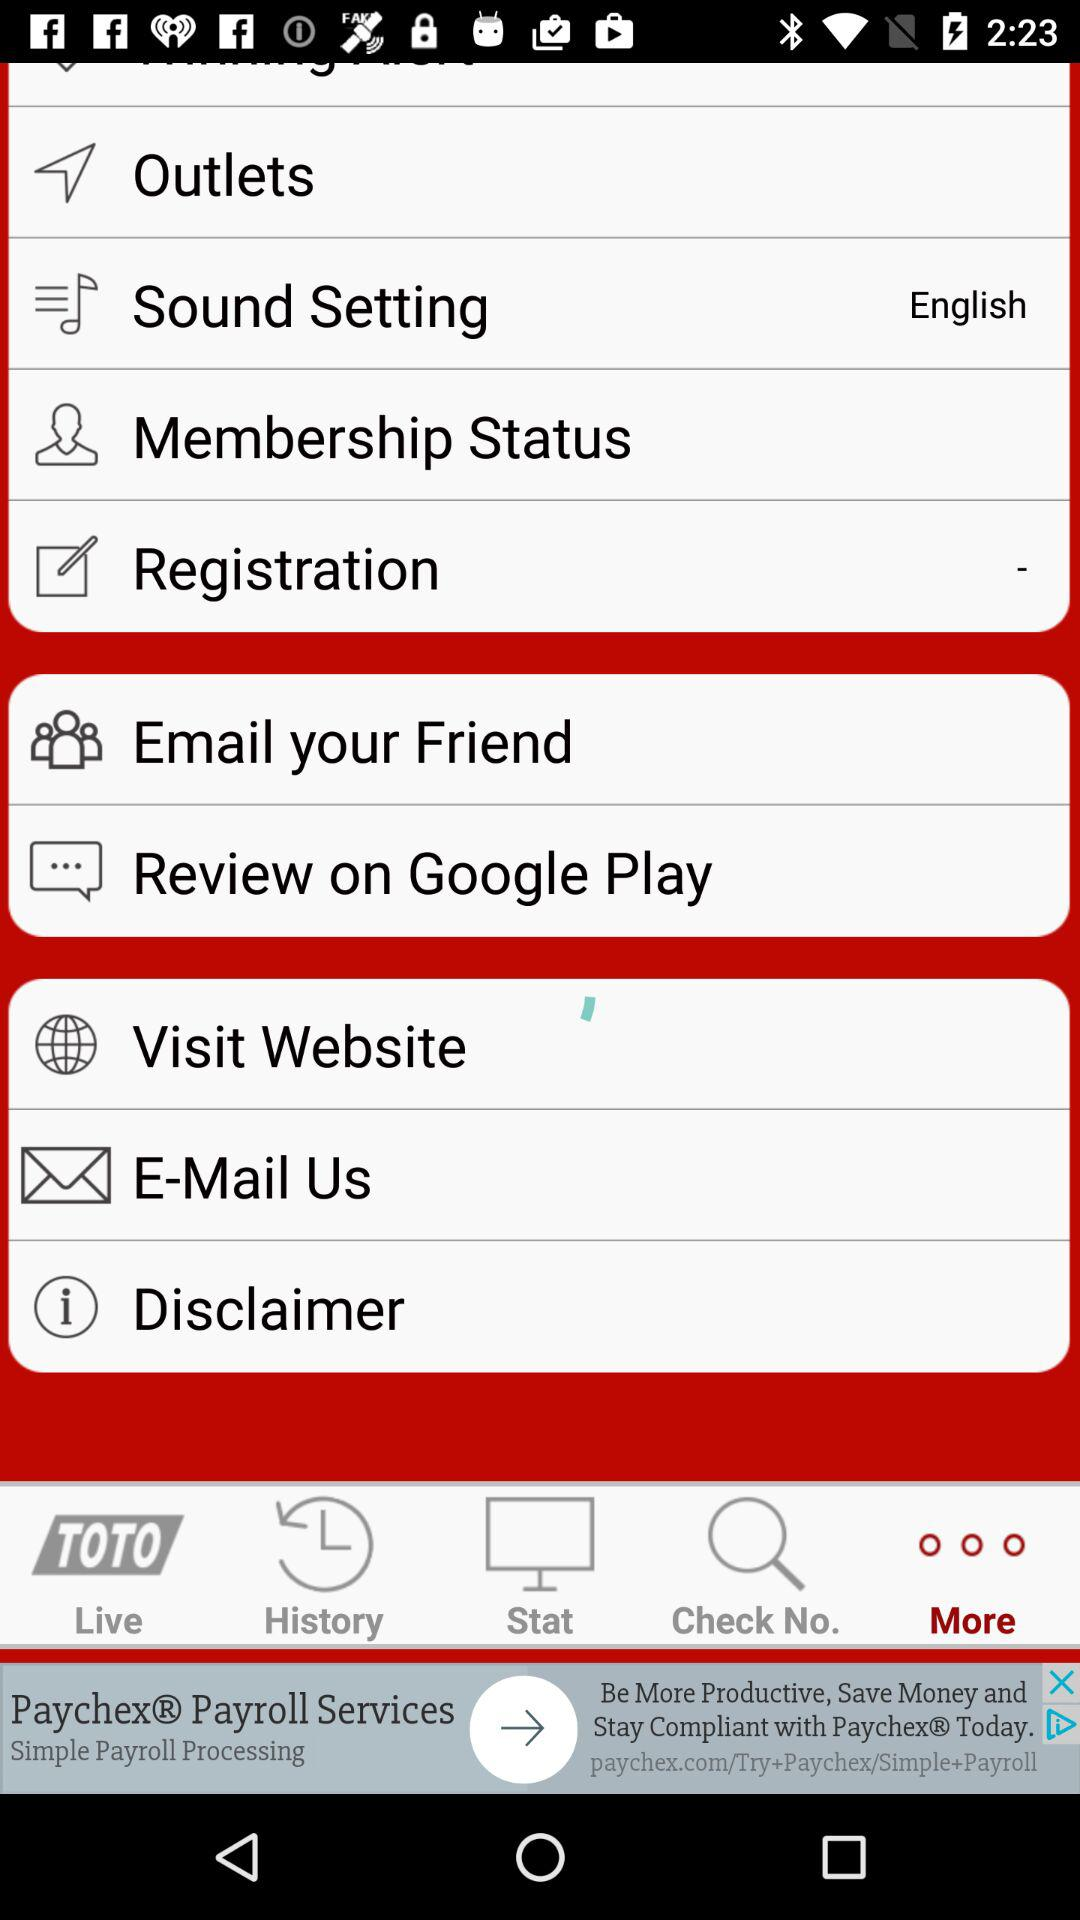Which tab is currently selected in the bottom bar? The tab that is currently selected in the bottom bar is "More". 